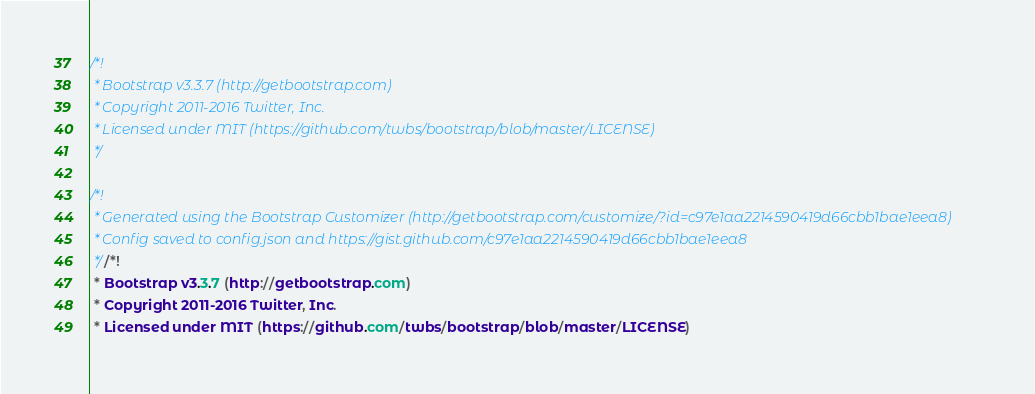Convert code to text. <code><loc_0><loc_0><loc_500><loc_500><_CSS_>/*!
 * Bootstrap v3.3.7 (http://getbootstrap.com)
 * Copyright 2011-2016 Twitter, Inc.
 * Licensed under MIT (https://github.com/twbs/bootstrap/blob/master/LICENSE)
 */

/*!
 * Generated using the Bootstrap Customizer (http://getbootstrap.com/customize/?id=c97e1aa2214590419d66cbb1bae1eea8)
 * Config saved to config.json and https://gist.github.com/c97e1aa2214590419d66cbb1bae1eea8
 *//*!
 * Bootstrap v3.3.7 (http://getbootstrap.com)
 * Copyright 2011-2016 Twitter, Inc.
 * Licensed under MIT (https://github.com/twbs/bootstrap/blob/master/LICENSE)</code> 